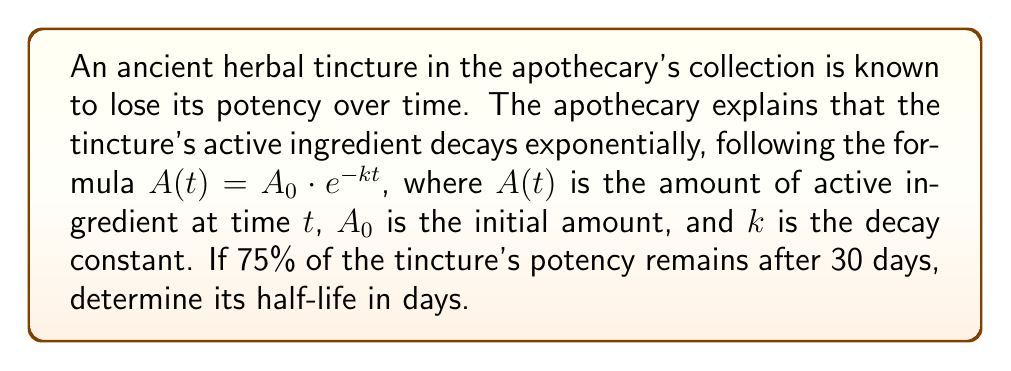Give your solution to this math problem. Let's approach this step-by-step:

1) The exponential decay formula is given as:
   $A(t) = A_0 \cdot e^{-kt}$

2) We know that after 30 days, 75% of the original amount remains. This means:
   $A(30) = 0.75 \cdot A_0$

3) Substituting this into our original equation:
   $0.75 \cdot A_0 = A_0 \cdot e^{-k \cdot 30}$

4) The $A_0$ terms cancel out:
   $0.75 = e^{-30k}$

5) Taking the natural log of both sides:
   $\ln(0.75) = -30k$

6) Solving for $k$:
   $k = -\frac{\ln(0.75)}{30} \approx 0.009621$ per day

7) Now, to find the half-life, we use the formula:
   $t_{1/2} = \frac{\ln(2)}{k}$

8) Substituting our value for $k$:
   $t_{1/2} = \frac{\ln(2)}{0.009621} \approx 72.07$ days

Therefore, the half-life of the tincture is approximately 72.07 days.
Answer: 72.07 days 